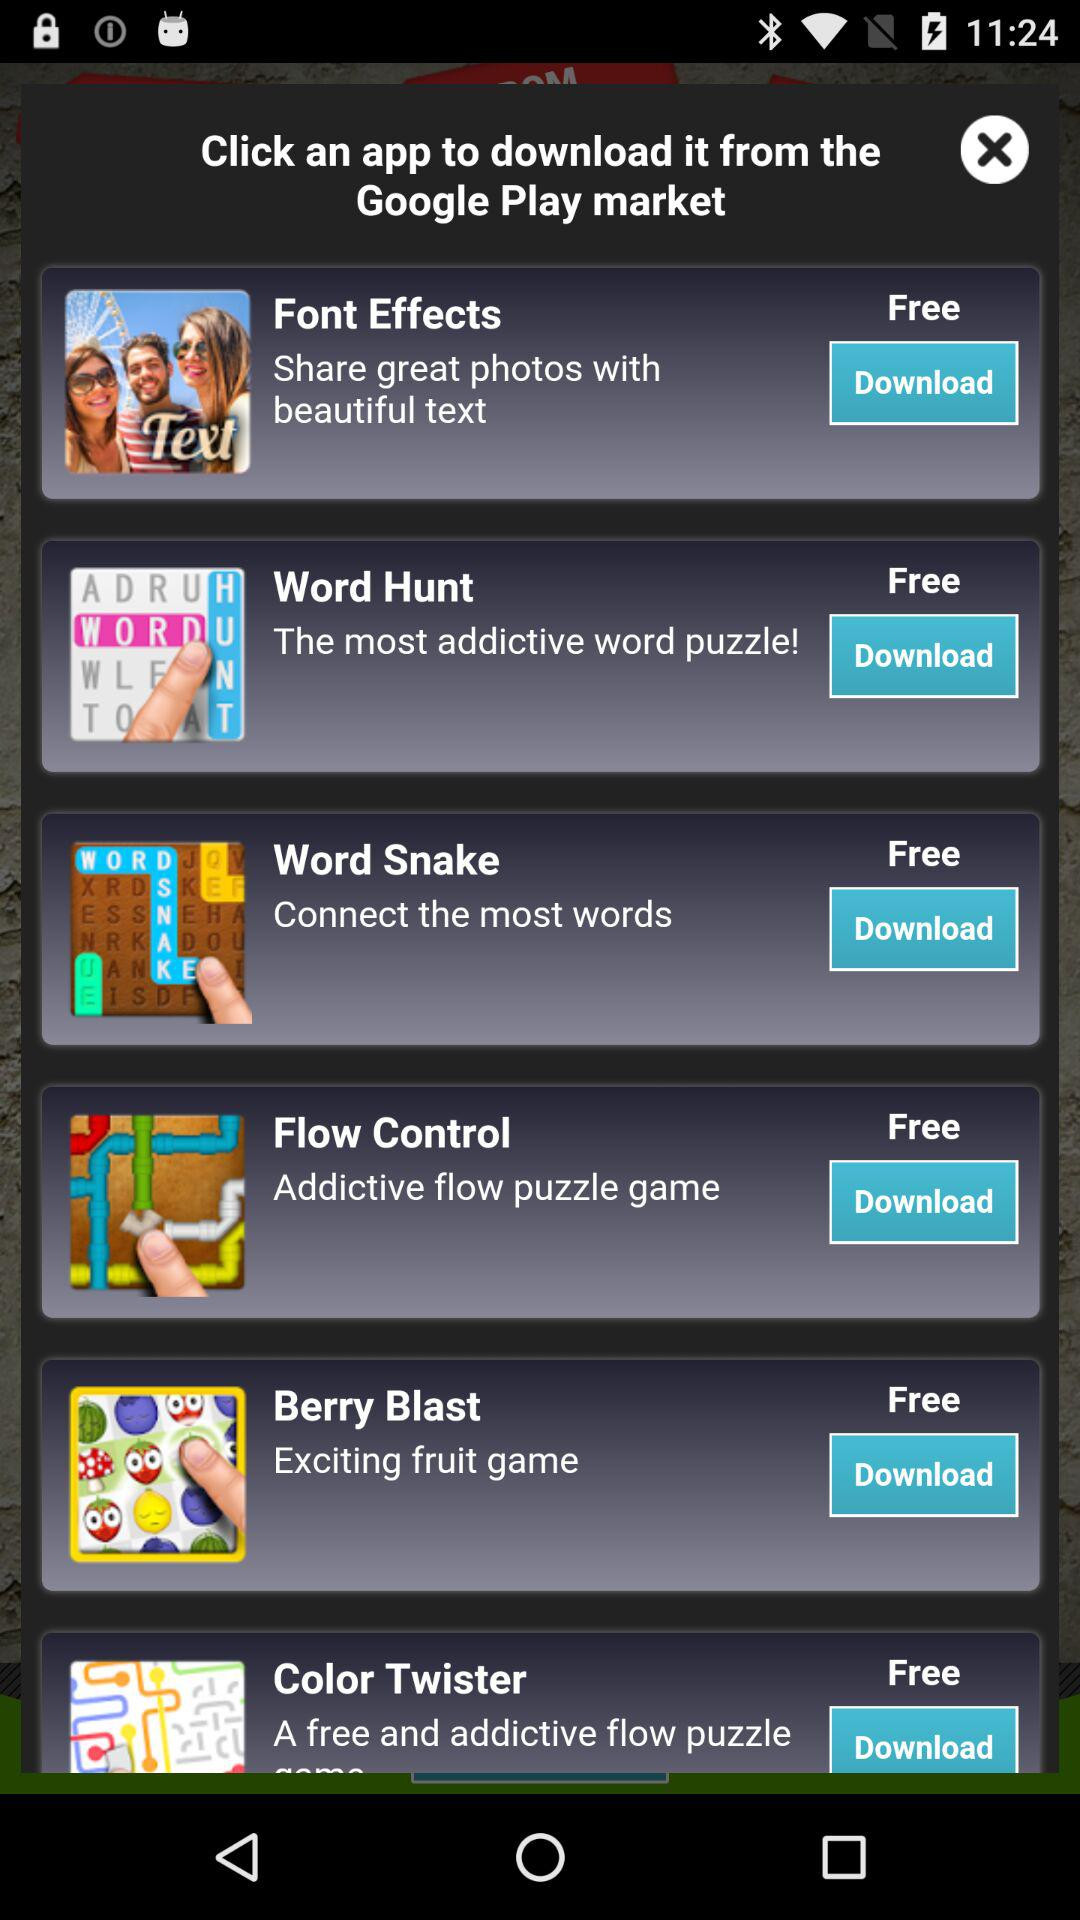What is the cost of the "Word Hunt" application? The cost of the "Word Hunt" application is free. 